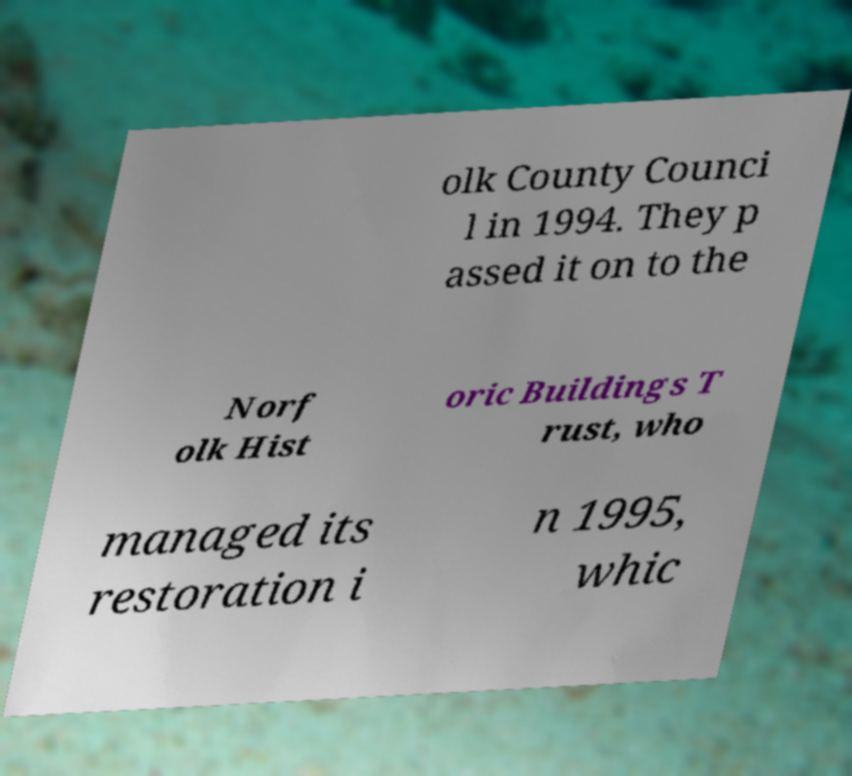Could you assist in decoding the text presented in this image and type it out clearly? olk County Counci l in 1994. They p assed it on to the Norf olk Hist oric Buildings T rust, who managed its restoration i n 1995, whic 